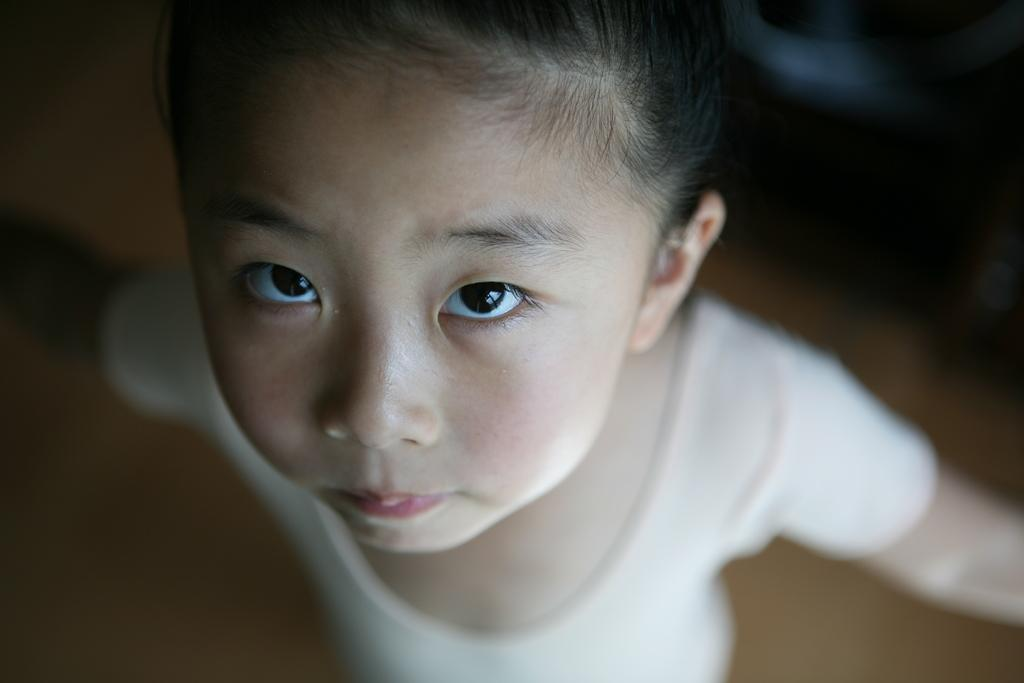What is the main subject of the image? There is a girl standing in the image. Can you describe the background of the image? The background of the image is blurry. What song is the girl singing in the image? There is no indication in the image that the girl is singing, so it cannot be determined from the picture. 